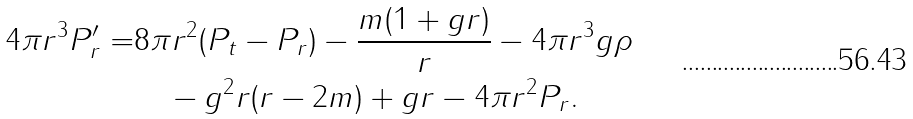<formula> <loc_0><loc_0><loc_500><loc_500>4 \pi r ^ { 3 } P _ { r } ^ { \prime } = & 8 \pi r ^ { 2 } ( P _ { t } - P _ { r } ) - \frac { m ( 1 + g r ) } { r } - 4 \pi r ^ { 3 } g \rho \\ & \quad - g ^ { 2 } r ( r - 2 m ) + g r - 4 \pi r ^ { 2 } P _ { r } .</formula> 